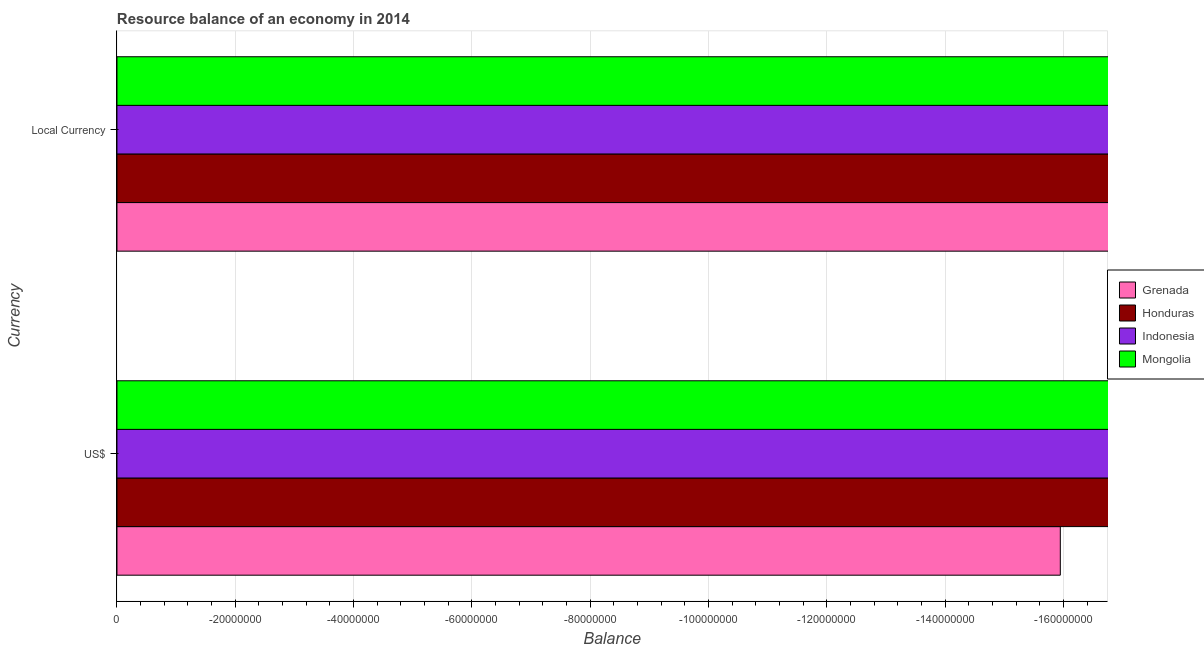How many bars are there on the 1st tick from the top?
Your answer should be compact. 0. How many bars are there on the 2nd tick from the bottom?
Provide a short and direct response. 0. What is the label of the 2nd group of bars from the top?
Your response must be concise. US$. What is the total resource balance in constant us$ in the graph?
Offer a terse response. 0. What is the difference between the resource balance in constant us$ in Indonesia and the resource balance in us$ in Mongolia?
Provide a short and direct response. 0. Are all the bars in the graph horizontal?
Provide a short and direct response. Yes. How many countries are there in the graph?
Provide a succinct answer. 4. Where does the legend appear in the graph?
Keep it short and to the point. Center right. How are the legend labels stacked?
Your answer should be compact. Vertical. What is the title of the graph?
Provide a succinct answer. Resource balance of an economy in 2014. Does "Hong Kong" appear as one of the legend labels in the graph?
Give a very brief answer. No. What is the label or title of the X-axis?
Provide a succinct answer. Balance. What is the label or title of the Y-axis?
Provide a short and direct response. Currency. What is the Balance of Grenada in US$?
Keep it short and to the point. 0. What is the Balance of Mongolia in US$?
Give a very brief answer. 0. What is the Balance in Honduras in Local Currency?
Make the answer very short. 0. What is the Balance in Indonesia in Local Currency?
Ensure brevity in your answer.  0. What is the Balance of Mongolia in Local Currency?
Your answer should be compact. 0. What is the total Balance of Grenada in the graph?
Your response must be concise. 0. What is the total Balance in Indonesia in the graph?
Your response must be concise. 0. What is the average Balance in Grenada per Currency?
Your answer should be very brief. 0. What is the average Balance in Indonesia per Currency?
Provide a succinct answer. 0. What is the average Balance of Mongolia per Currency?
Your response must be concise. 0. 